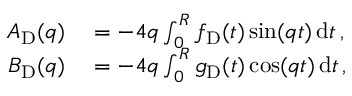Convert formula to latex. <formula><loc_0><loc_0><loc_500><loc_500>\begin{array} { r l } { A _ { D } ( q ) } & = - 4 q \int _ { 0 } ^ { R } f _ { D } ( t ) \sin ( q t ) \, d t \, , } \\ { B _ { D } ( q ) } & = - 4 q \int _ { 0 } ^ { R } g _ { D } ( t ) \cos ( q t ) \, d t \, , } \end{array}</formula> 